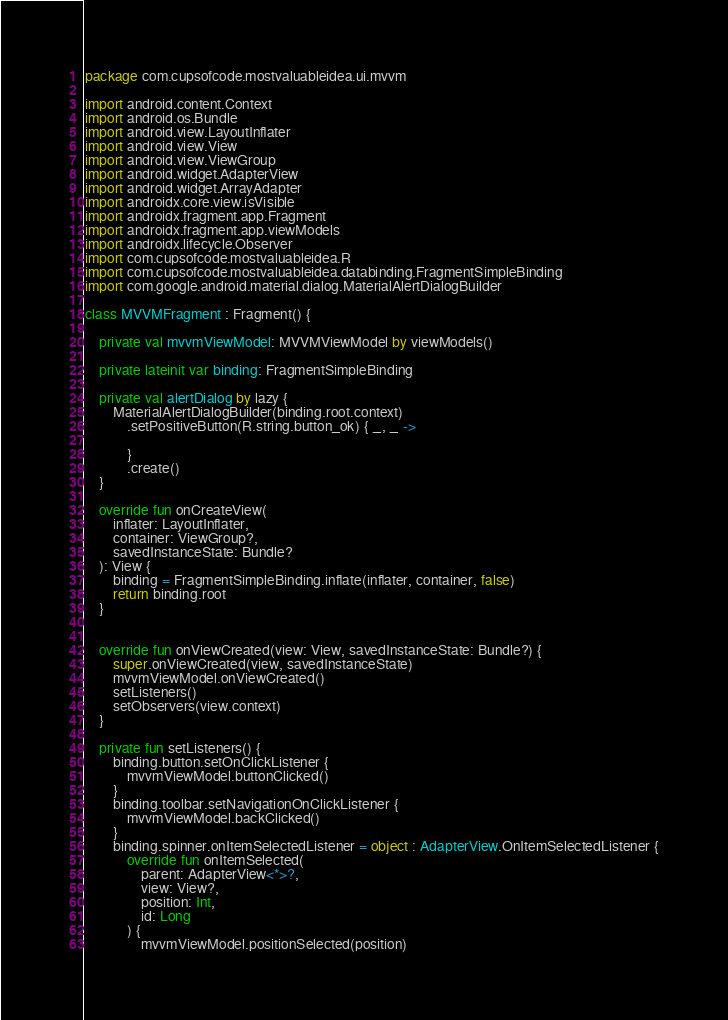Convert code to text. <code><loc_0><loc_0><loc_500><loc_500><_Kotlin_>package com.cupsofcode.mostvaluableidea.ui.mvvm

import android.content.Context
import android.os.Bundle
import android.view.LayoutInflater
import android.view.View
import android.view.ViewGroup
import android.widget.AdapterView
import android.widget.ArrayAdapter
import androidx.core.view.isVisible
import androidx.fragment.app.Fragment
import androidx.fragment.app.viewModels
import androidx.lifecycle.Observer
import com.cupsofcode.mostvaluableidea.R
import com.cupsofcode.mostvaluableidea.databinding.FragmentSimpleBinding
import com.google.android.material.dialog.MaterialAlertDialogBuilder

class MVVMFragment : Fragment() {

    private val mvvmViewModel: MVVMViewModel by viewModels()

    private lateinit var binding: FragmentSimpleBinding

    private val alertDialog by lazy {
        MaterialAlertDialogBuilder(binding.root.context)
            .setPositiveButton(R.string.button_ok) { _, _ ->

            }
            .create()
    }

    override fun onCreateView(
        inflater: LayoutInflater,
        container: ViewGroup?,
        savedInstanceState: Bundle?
    ): View {
        binding = FragmentSimpleBinding.inflate(inflater, container, false)
        return binding.root
    }


    override fun onViewCreated(view: View, savedInstanceState: Bundle?) {
        super.onViewCreated(view, savedInstanceState)
        mvvmViewModel.onViewCreated()
        setListeners()
        setObservers(view.context)
    }

    private fun setListeners() {
        binding.button.setOnClickListener {
            mvvmViewModel.buttonClicked()
        }
        binding.toolbar.setNavigationOnClickListener {
            mvvmViewModel.backClicked()
        }
        binding.spinner.onItemSelectedListener = object : AdapterView.OnItemSelectedListener {
            override fun onItemSelected(
                parent: AdapterView<*>?,
                view: View?,
                position: Int,
                id: Long
            ) {
                mvvmViewModel.positionSelected(position)</code> 